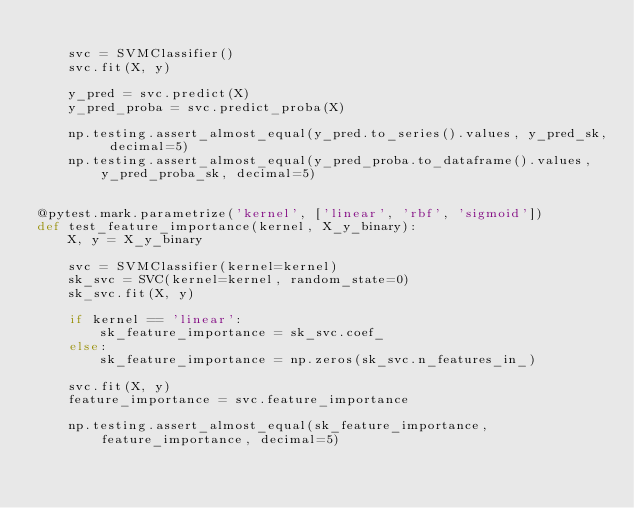Convert code to text. <code><loc_0><loc_0><loc_500><loc_500><_Python_>
    svc = SVMClassifier()
    svc.fit(X, y)

    y_pred = svc.predict(X)
    y_pred_proba = svc.predict_proba(X)

    np.testing.assert_almost_equal(y_pred.to_series().values, y_pred_sk, decimal=5)
    np.testing.assert_almost_equal(y_pred_proba.to_dataframe().values, y_pred_proba_sk, decimal=5)


@pytest.mark.parametrize('kernel', ['linear', 'rbf', 'sigmoid'])
def test_feature_importance(kernel, X_y_binary):
    X, y = X_y_binary

    svc = SVMClassifier(kernel=kernel)
    sk_svc = SVC(kernel=kernel, random_state=0)
    sk_svc.fit(X, y)

    if kernel == 'linear':
        sk_feature_importance = sk_svc.coef_
    else:
        sk_feature_importance = np.zeros(sk_svc.n_features_in_)

    svc.fit(X, y)
    feature_importance = svc.feature_importance

    np.testing.assert_almost_equal(sk_feature_importance, feature_importance, decimal=5)
</code> 